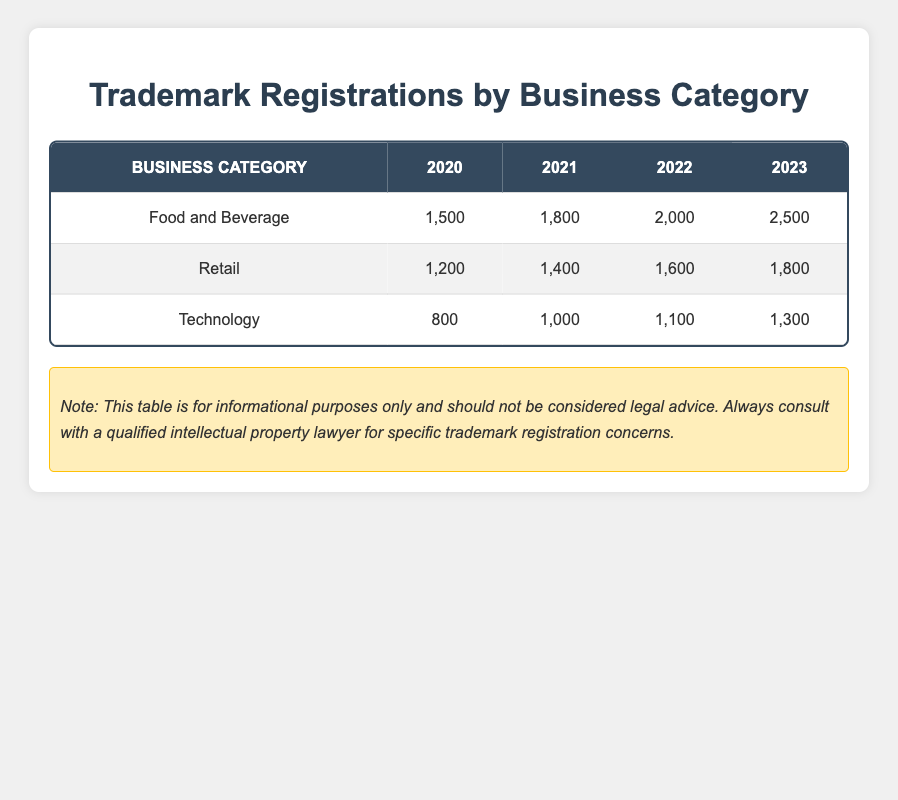What was the total number of trademark registrations in the Food and Beverage category from 2020 to 2023? To find the total number of trademark registrations in the Food and Beverage category, we sum the values for each year: 1500 (2020) + 1800 (2021) + 2000 (2022) + 2500 (2023) = 7800.
Answer: 7800 Which business category had the highest number of trademark registrations in 2022? From the table, we can directly compare the values for each business category in 2022: Food and Beverage has 2000, Retail has 1600, and Technology has 1100. Food and Beverage (2000) is the highest.
Answer: Food and Beverage Did the number of trademark registrations in the Technology category increase every year from 2020 to 2023? Looking at the Technology category: it has 800 in 2020, 1000 in 2021, 1100 in 2022, and 1300 in 2023. Each value is greater than the previous year's value, so yes, it increased every year.
Answer: Yes What is the average number of trademark registrations in the Retail category from 2020 to 2023? To calculate the average for the Retail category, we first sum the values: 1200 (2020) + 1400 (2021) + 1600 (2022) + 1800 (2023) = 6000. There are 4 years, so we divide by 4: 6000 / 4 = 1500.
Answer: 1500 In which year did the Food and Beverage category see the largest increase in trademark registrations compared to the previous year? We analyze the yearly registration numbers: from 2020 to 2021, the increase is 1800 - 1500 = 300; from 2021 to 2022, it is 2000 - 1800 = 200; and from 2022 to 2023, it is 2500 - 2000 = 500. The largest increase is from 2022 to 2023, which is 500.
Answer: 2022 to 2023 How many more trademark registrations were there for the Retail category in 2021 compared to 2020? Looking at the Retail category, in 2020 there were 1200 registrations and in 2021 there were 1400 registrations. We find the difference: 1400 - 1200 = 200.
Answer: 200 Is it true that the Technology category had a lower number of trademark registrations than both the Food and Beverage and Retail categories in all four years? Checking each year: In 2020, Technology had 800 (Food and Beverage: 1500, Retail: 1200). In 2021: Technology had 1000 (Food and Beverage: 1800, Retail: 1400). In 2022: Technology had 1100 (Food and Beverage: 2000, Retail: 1600). In 2023: Technology had 1300 (Food and Beverage: 2500, Retail: 1800). In all years, Technology had fewer registrations than both categories.
Answer: Yes What was the percentage increase in trademark registrations in the Food and Beverage category from 2020 to 2023? To calculate the percentage increase, we take the difference between the two years: 2500 (2023) - 1500 (2020) = 1000. Then we divide the increase by the original number: 1000 / 1500 = 0.6667. We multiply by 100 to express it as a percentage: 0.6667 * 100 = 66.67%.
Answer: 66.67% 